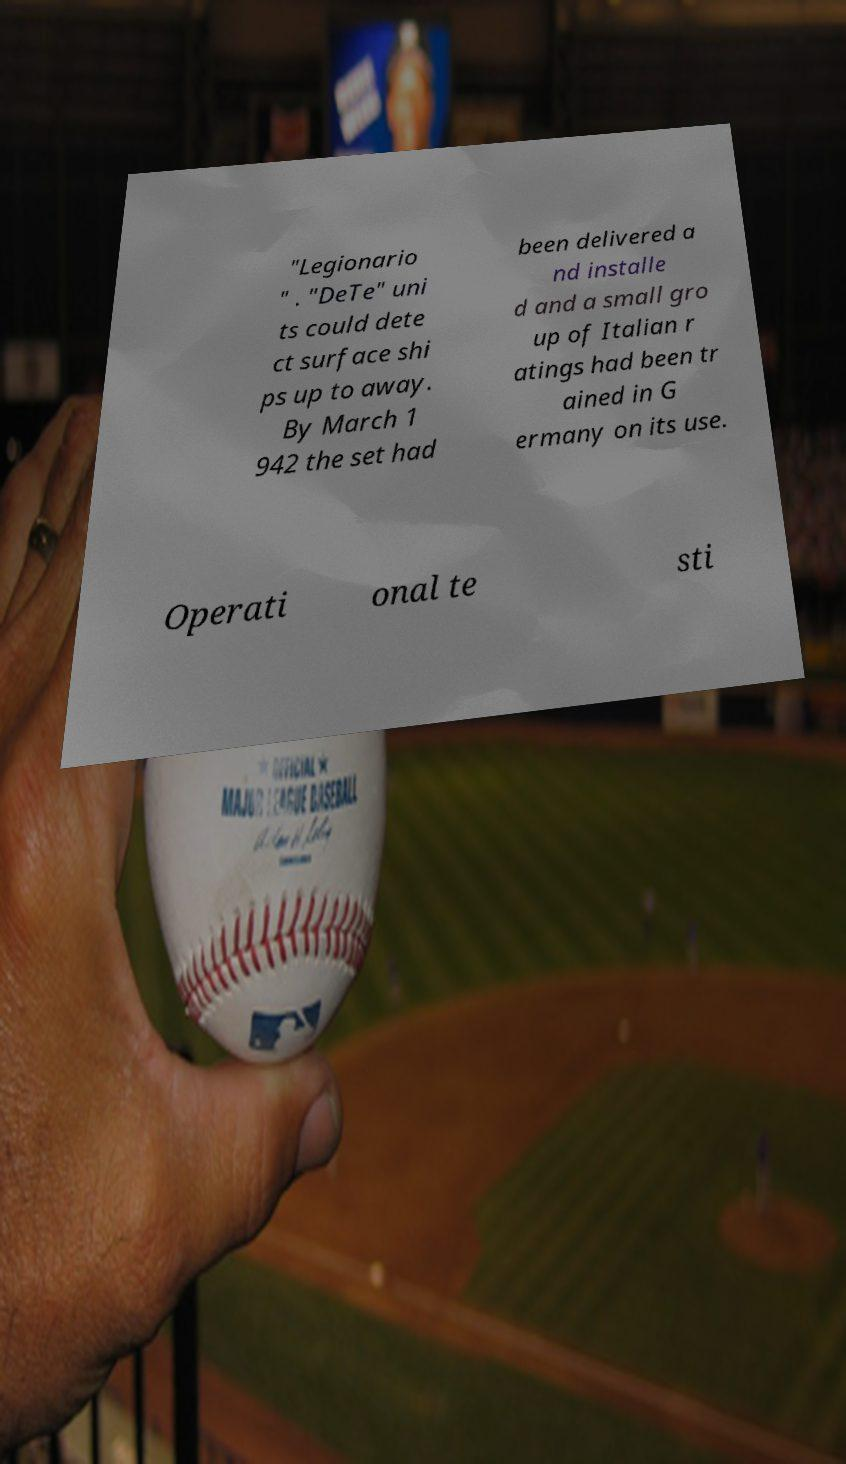Can you accurately transcribe the text from the provided image for me? "Legionario " . "DeTe" uni ts could dete ct surface shi ps up to away. By March 1 942 the set had been delivered a nd installe d and a small gro up of Italian r atings had been tr ained in G ermany on its use. Operati onal te sti 